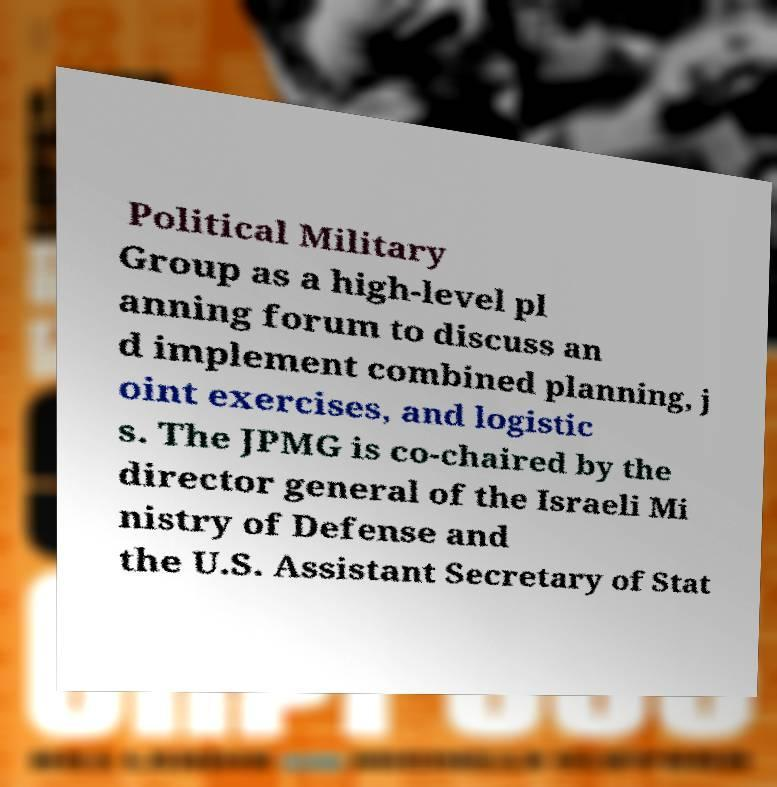Can you read and provide the text displayed in the image?This photo seems to have some interesting text. Can you extract and type it out for me? Political Military Group as a high-level pl anning forum to discuss an d implement combined planning, j oint exercises, and logistic s. The JPMG is co-chaired by the director general of the Israeli Mi nistry of Defense and the U.S. Assistant Secretary of Stat 